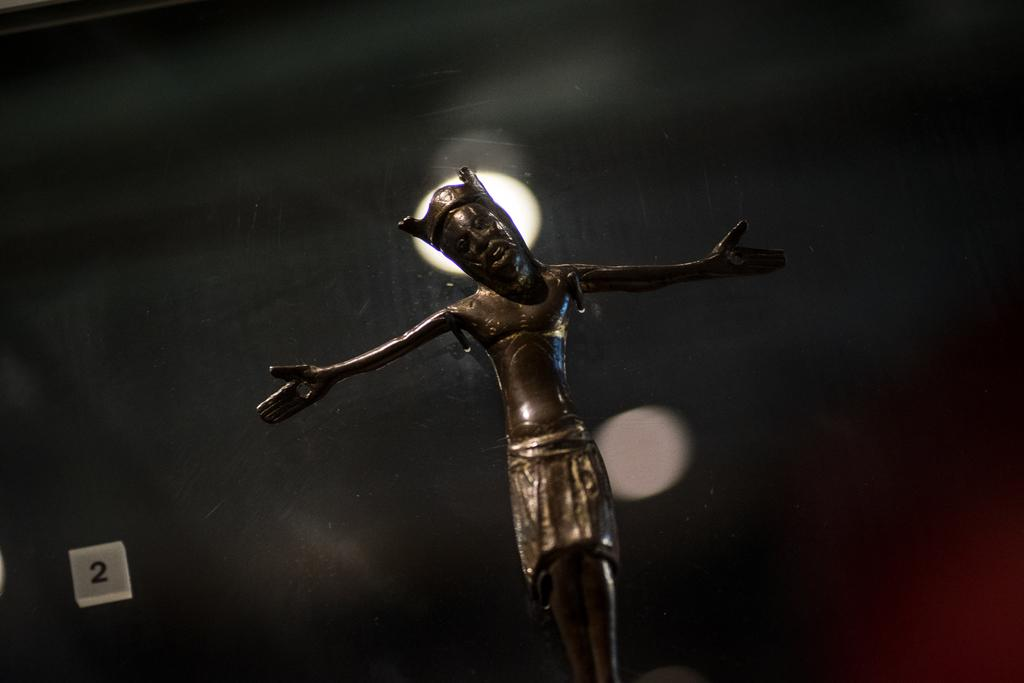What is the main subject of the image? There is a statue of a person in the image. What is the statue wearing? The statue is wearing a crown. Can you describe any other elements in the image? There is a light in the image. How would you describe the background of the image? The background is dark and blurred. What type of war is depicted in the image? There is no depiction of war in the image; it features a statue wearing a crown with a light and a dark, blurred background. What time of day is it in the image? The image does not provide any information about the time of day, as it only shows a statue, a light, and a dark, blurred background. 